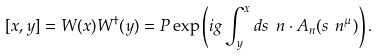Convert formula to latex. <formula><loc_0><loc_0><loc_500><loc_500>[ x , y ] = W ( x ) W ^ { \dagger } ( y ) = P \exp \left ( i g \int ^ { x } _ { y } d s \ n \cdot A _ { n } ( s \ n ^ { \mu } ) \right ) .</formula> 